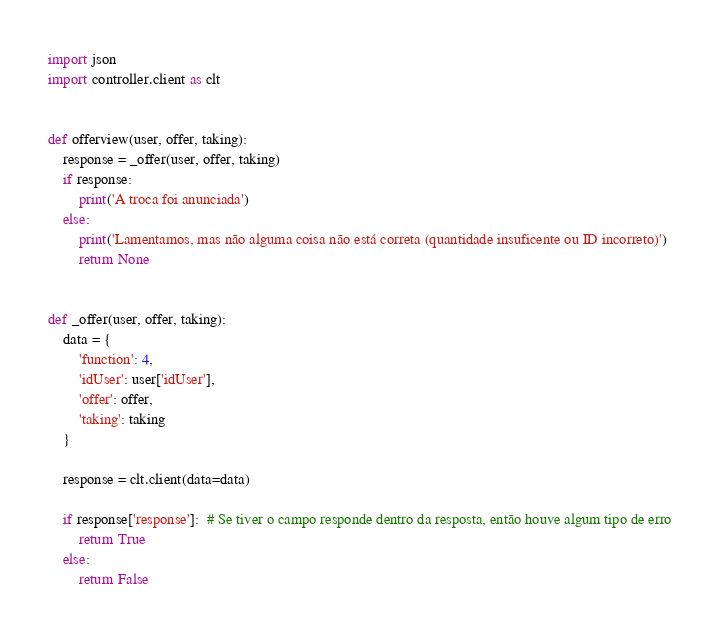Convert code to text. <code><loc_0><loc_0><loc_500><loc_500><_Python_>import json
import controller.client as clt


def offerview(user, offer, taking):
    response = _offer(user, offer, taking)
    if response:
        print('A troca foi anunciada')
    else:
        print('Lamentamos, mas não alguma coisa não está correta (quantidade insuficente ou ID incorreto)')
        return None


def _offer(user, offer, taking):
    data = {
        'function': 4,
        'idUser': user['idUser'],
        'offer': offer,
        'taking': taking
    }

    response = clt.client(data=data)

    if response['response']:  # Se tiver o campo responde dentro da resposta, então houve algum tipo de erro
        return True
    else:
        return False
</code> 